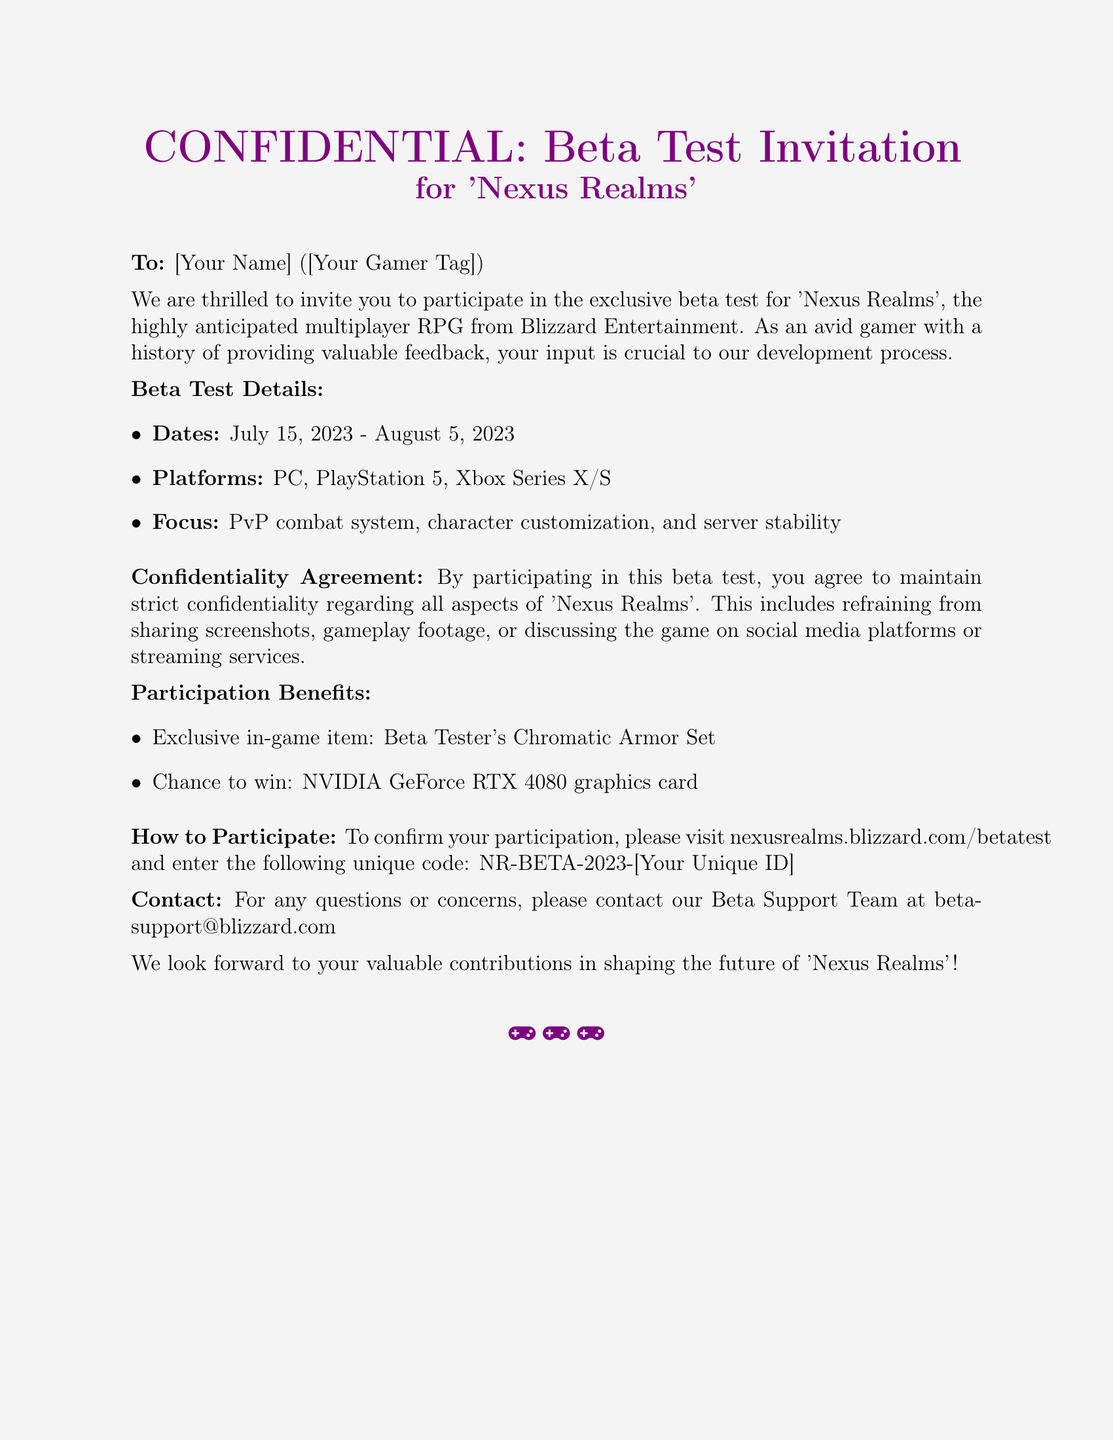What is the name of the game being tested? The name of the game mentioned in the document is 'Nexus Realms'.
Answer: 'Nexus Realms' What are the beta test dates? The document states the beta test dates are from July 15, 2023 to August 5, 2023.
Answer: July 15, 2023 - August 5, 2023 Which platforms are included in the beta test? The document lists the platforms for the beta test as PC, PlayStation 5, and Xbox Series X/S.
Answer: PC, PlayStation 5, Xbox Series X/S What is the exclusive in-game item for participants? The document mentions that participants will receive the Beta Tester's Chromatic Armor Set as an exclusive item.
Answer: Beta Tester's Chromatic Armor Set What must participants agree to in terms of information sharing? Participants are required to maintain strict confidentiality regarding all aspects of 'Nexus Realms'.
Answer: Strict confidentiality What is the unique code for participation confirmation? The document provides the structure for the unique code, which includes NR-BETA-2023 followed by a unique ID.
Answer: NR-BETA-2023-[Your Unique ID] What is one of the participation benefits apart from the in-game item? According to the document, participants have a chance to win an NVIDIA GeForce RTX 4080 graphics card.
Answer: NVIDIA GeForce RTX 4080 Who can participants contact for support? The document provides an email address for support, which is betasupport@blizzard.com.
Answer: betasupport@blizzard.com 